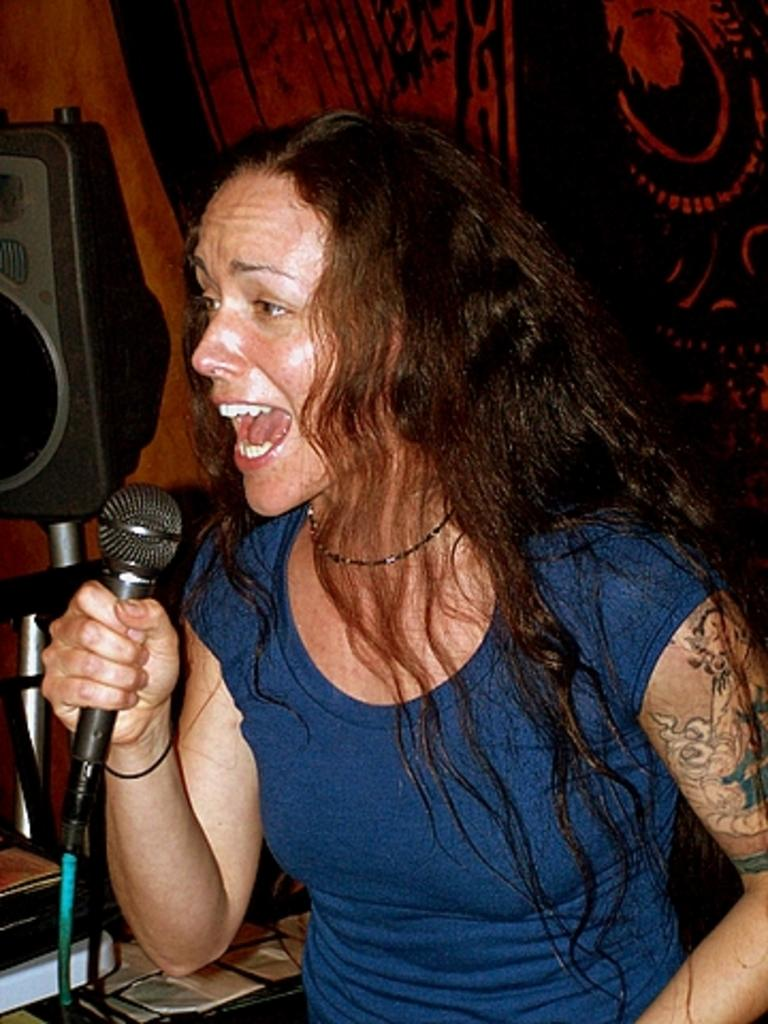Who is the main subject in the image? There is a woman in the image. What is the woman holding in her hand? The woman is holding a microphone in her hand. What is the woman doing in the image? The woman is singing. Can you describe any additional features of the woman? There is a tattoo on the woman's hand. What level of amusement can be seen in the woman's bath in the image? There is no bath or amusement level present in the image; it features a woman holding a microphone and singing. 